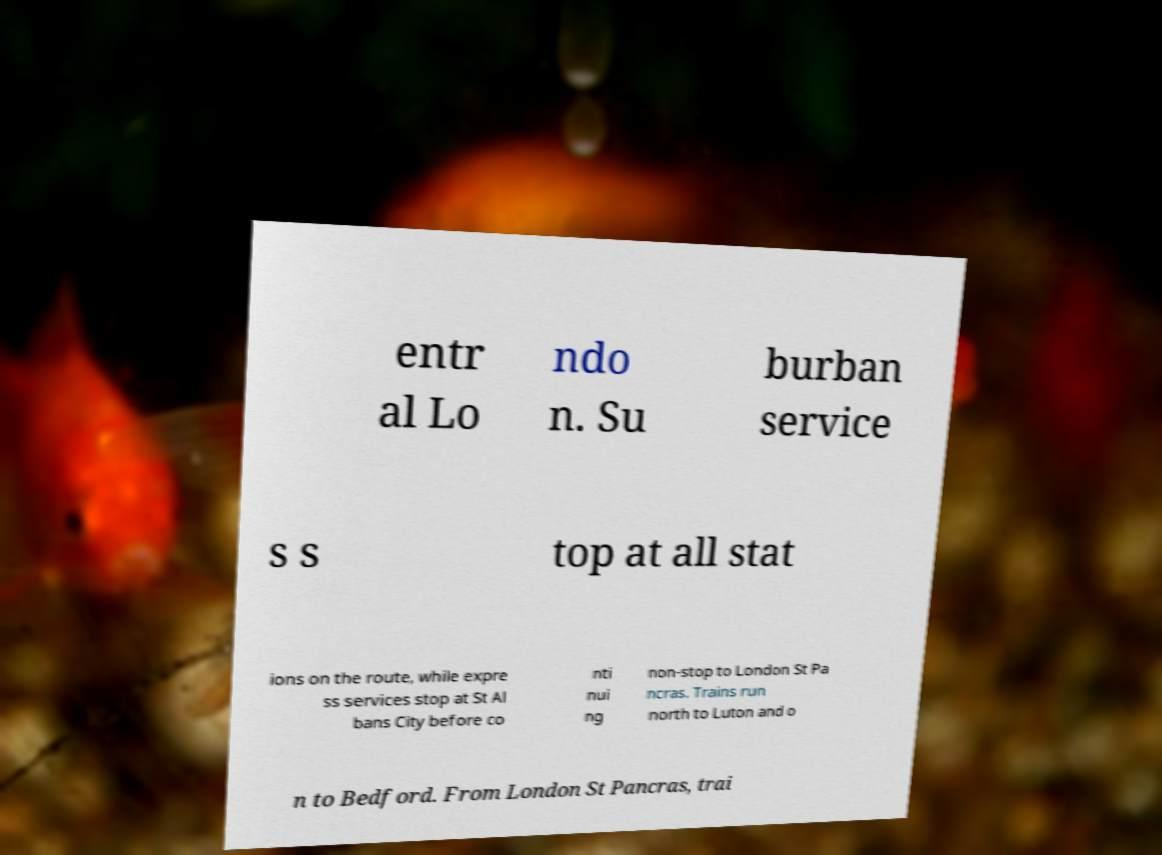What messages or text are displayed in this image? I need them in a readable, typed format. entr al Lo ndo n. Su burban service s s top at all stat ions on the route, while expre ss services stop at St Al bans City before co nti nui ng non-stop to London St Pa ncras. Trains run north to Luton and o n to Bedford. From London St Pancras, trai 